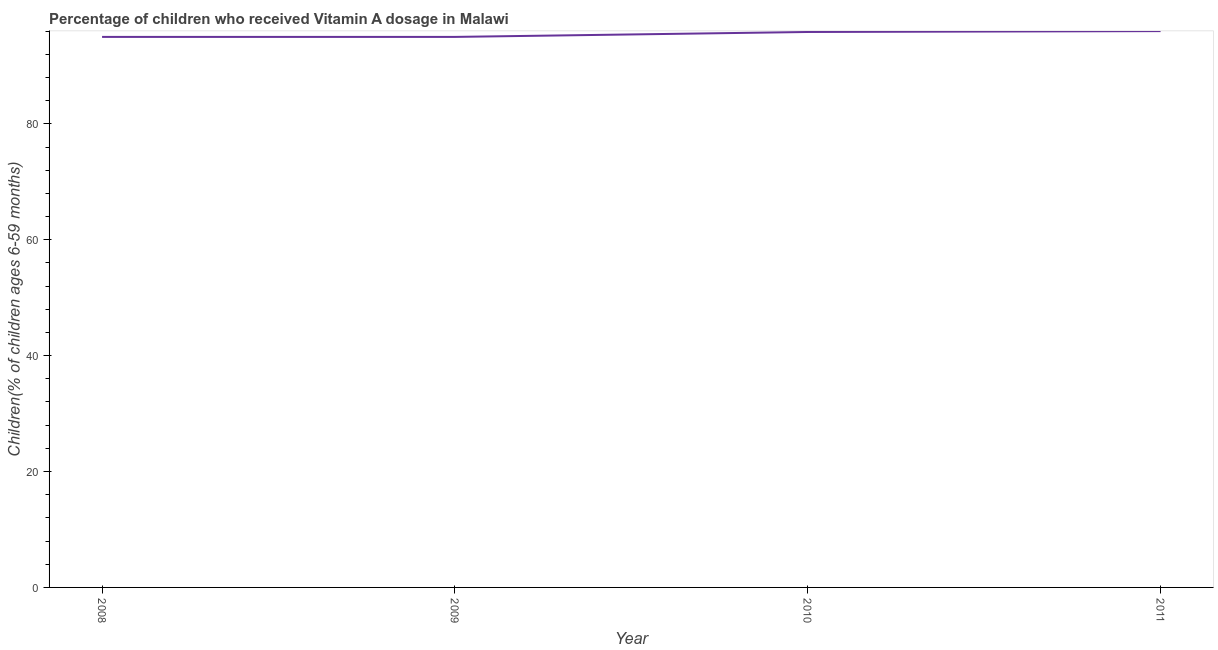What is the vitamin a supplementation coverage rate in 2009?
Offer a very short reply. 95. Across all years, what is the maximum vitamin a supplementation coverage rate?
Your answer should be very brief. 96. Across all years, what is the minimum vitamin a supplementation coverage rate?
Your answer should be very brief. 95. In which year was the vitamin a supplementation coverage rate maximum?
Provide a short and direct response. 2011. What is the sum of the vitamin a supplementation coverage rate?
Your answer should be compact. 381.85. What is the average vitamin a supplementation coverage rate per year?
Give a very brief answer. 95.46. What is the median vitamin a supplementation coverage rate?
Your answer should be very brief. 95.42. In how many years, is the vitamin a supplementation coverage rate greater than 80 %?
Provide a short and direct response. 4. What is the ratio of the vitamin a supplementation coverage rate in 2009 to that in 2011?
Offer a very short reply. 0.99. Is the vitamin a supplementation coverage rate in 2008 less than that in 2009?
Provide a short and direct response. No. Is the difference between the vitamin a supplementation coverage rate in 2008 and 2010 greater than the difference between any two years?
Provide a short and direct response. No. What is the difference between the highest and the second highest vitamin a supplementation coverage rate?
Offer a terse response. 0.15. Is the sum of the vitamin a supplementation coverage rate in 2008 and 2009 greater than the maximum vitamin a supplementation coverage rate across all years?
Offer a very short reply. Yes. What is the difference between the highest and the lowest vitamin a supplementation coverage rate?
Provide a short and direct response. 1. Does the vitamin a supplementation coverage rate monotonically increase over the years?
Your answer should be compact. No. How many lines are there?
Offer a very short reply. 1. How many years are there in the graph?
Your answer should be compact. 4. Are the values on the major ticks of Y-axis written in scientific E-notation?
Offer a very short reply. No. What is the title of the graph?
Offer a very short reply. Percentage of children who received Vitamin A dosage in Malawi. What is the label or title of the X-axis?
Your answer should be very brief. Year. What is the label or title of the Y-axis?
Ensure brevity in your answer.  Children(% of children ages 6-59 months). What is the Children(% of children ages 6-59 months) of 2008?
Offer a very short reply. 95. What is the Children(% of children ages 6-59 months) in 2009?
Your response must be concise. 95. What is the Children(% of children ages 6-59 months) of 2010?
Make the answer very short. 95.85. What is the Children(% of children ages 6-59 months) of 2011?
Keep it short and to the point. 96. What is the difference between the Children(% of children ages 6-59 months) in 2008 and 2010?
Offer a terse response. -0.85. What is the difference between the Children(% of children ages 6-59 months) in 2008 and 2011?
Give a very brief answer. -1. What is the difference between the Children(% of children ages 6-59 months) in 2009 and 2010?
Make the answer very short. -0.85. What is the difference between the Children(% of children ages 6-59 months) in 2009 and 2011?
Give a very brief answer. -1. What is the difference between the Children(% of children ages 6-59 months) in 2010 and 2011?
Your answer should be compact. -0.15. What is the ratio of the Children(% of children ages 6-59 months) in 2008 to that in 2010?
Give a very brief answer. 0.99. What is the ratio of the Children(% of children ages 6-59 months) in 2008 to that in 2011?
Provide a succinct answer. 0.99. What is the ratio of the Children(% of children ages 6-59 months) in 2010 to that in 2011?
Offer a terse response. 1. 